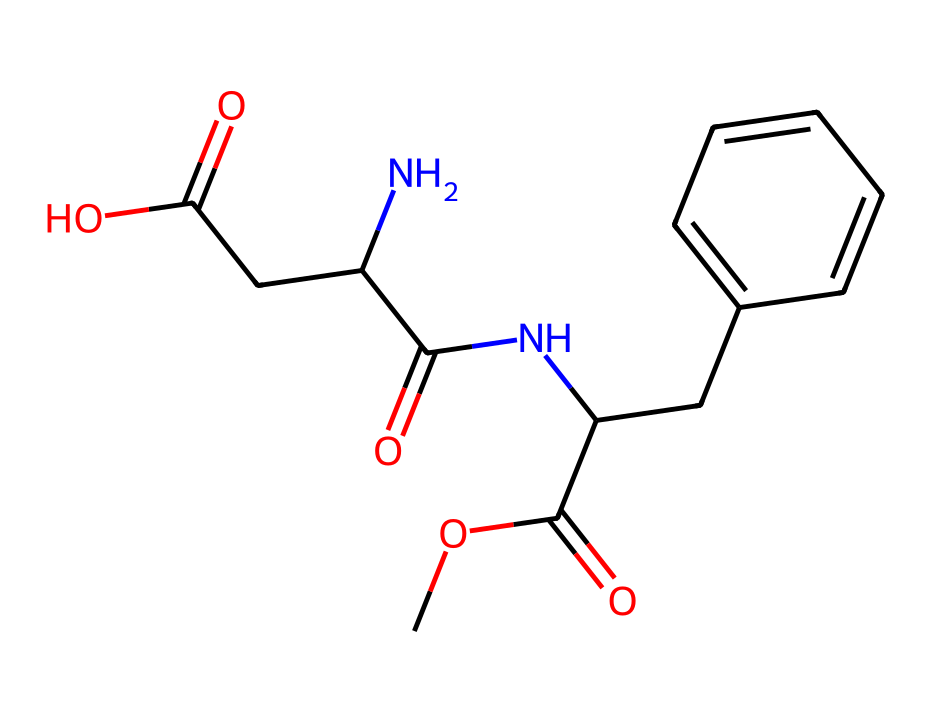What type of functional groups are present in this chemical? This chemical contains several functional groups: the ester group (COC(=O)) and the amide group (NC(=O)). Additionally, there is a carboxylic acid group (CC(=O)O).
Answer: ester, amide, carboxylic acid How many carbon atoms does this molecule have? By analyzing the SMILES representation, we can count the carbon atoms present in the entire molecule. It consists of 12 carbon atoms in total based on the structure.
Answer: 12 What is the base structure of this compound? The compound appears to be a modified amino acid derivative, given the presence of both amino (NH) and carboxyl (COOH) functional groups.
Answer: amino acid derivative What does the nitrogen atom indicate about this compound? The presence of the nitrogen atom suggests that this molecule includes an amino group, indicating it may behave like an amine and influence taste characteristics, commonly found in sweeteners.
Answer: amino group How many rings are present in the structure? Analyzing the structure reveals one aromatic ring as indicated by the cyclic arrangement of carbon atoms and their alternating double bonds in the benzene-like structure.
Answer: one Does this compound contain any chiral centers? By examining the carbon atoms for tetravalent arrangements (four different substituents), we can identify that there is at least one chiral center in the structure, related to the amino acid component.
Answer: yes 